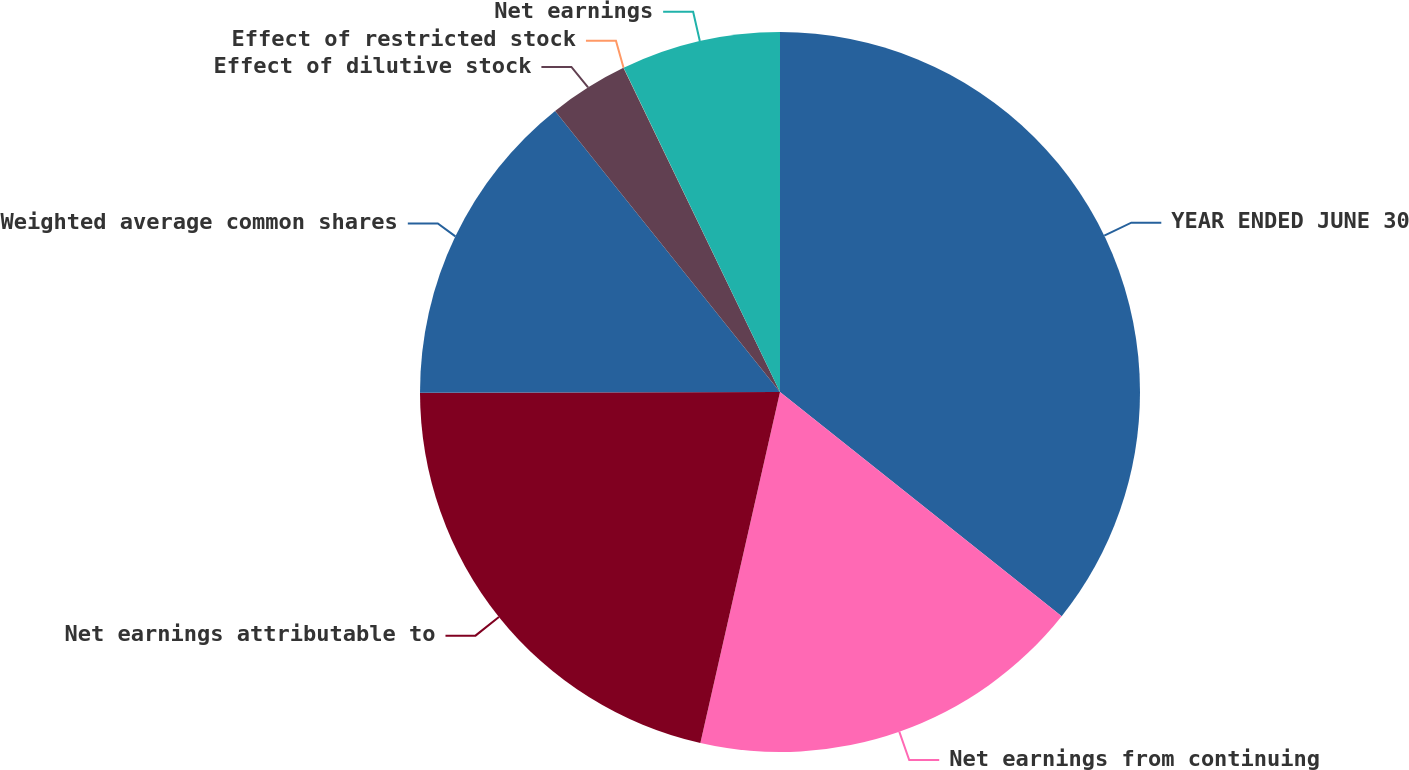Convert chart to OTSL. <chart><loc_0><loc_0><loc_500><loc_500><pie_chart><fcel>YEAR ENDED JUNE 30<fcel>Net earnings from continuing<fcel>Net earnings attributable to<fcel>Weighted average common shares<fcel>Effect of dilutive stock<fcel>Effect of restricted stock<fcel>Net earnings<nl><fcel>35.7%<fcel>17.85%<fcel>21.42%<fcel>14.29%<fcel>3.58%<fcel>0.01%<fcel>7.15%<nl></chart> 